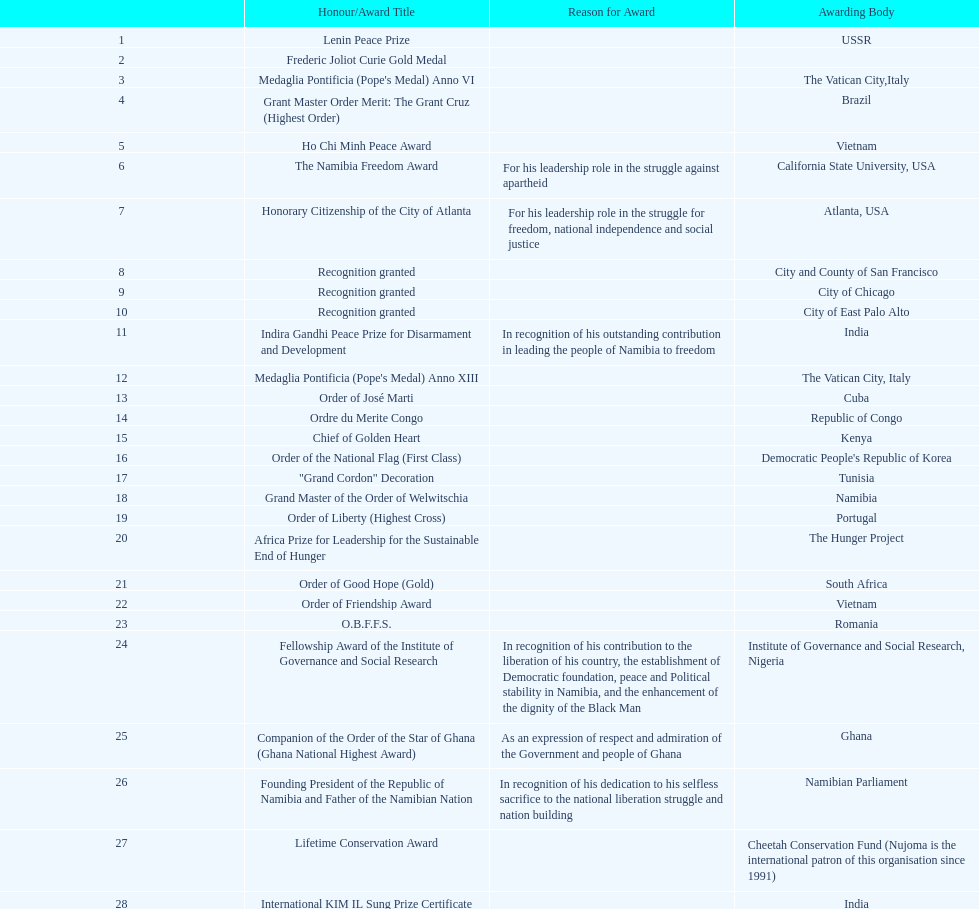Give me the full table as a dictionary. {'header': ['', 'Honour/Award Title', 'Reason for Award', 'Awarding Body'], 'rows': [['1', 'Lenin Peace Prize', '', 'USSR'], ['2', 'Frederic Joliot Curie Gold Medal', '', ''], ['3', "Medaglia Pontificia (Pope's Medal) Anno VI", '', 'The Vatican City,Italy'], ['4', 'Grant Master Order Merit: The Grant Cruz (Highest Order)', '', 'Brazil'], ['5', 'Ho Chi Minh Peace Award', '', 'Vietnam'], ['6', 'The Namibia Freedom Award', 'For his leadership role in the struggle against apartheid', 'California State University, USA'], ['7', 'Honorary Citizenship of the City of Atlanta', 'For his leadership role in the struggle for freedom, national independence and social justice', 'Atlanta, USA'], ['8', 'Recognition granted', '', 'City and County of San Francisco'], ['9', 'Recognition granted', '', 'City of Chicago'], ['10', 'Recognition granted', '', 'City of East Palo Alto'], ['11', 'Indira Gandhi Peace Prize for Disarmament and Development', 'In recognition of his outstanding contribution in leading the people of Namibia to freedom', 'India'], ['12', "Medaglia Pontificia (Pope's Medal) Anno XIII", '', 'The Vatican City, Italy'], ['13', 'Order of José Marti', '', 'Cuba'], ['14', 'Ordre du Merite Congo', '', 'Republic of Congo'], ['15', 'Chief of Golden Heart', '', 'Kenya'], ['16', 'Order of the National Flag (First Class)', '', "Democratic People's Republic of Korea"], ['17', '"Grand Cordon" Decoration', '', 'Tunisia'], ['18', 'Grand Master of the Order of Welwitschia', '', 'Namibia'], ['19', 'Order of Liberty (Highest Cross)', '', 'Portugal'], ['20', 'Africa Prize for Leadership for the Sustainable End of Hunger', '', 'The Hunger Project'], ['21', 'Order of Good Hope (Gold)', '', 'South Africa'], ['22', 'Order of Friendship Award', '', 'Vietnam'], ['23', 'O.B.F.F.S.', '', 'Romania'], ['24', 'Fellowship Award of the Institute of Governance and Social Research', 'In recognition of his contribution to the liberation of his country, the establishment of Democratic foundation, peace and Political stability in Namibia, and the enhancement of the dignity of the Black Man', 'Institute of Governance and Social Research, Nigeria'], ['25', 'Companion of the Order of the Star of Ghana (Ghana National Highest Award)', 'As an expression of respect and admiration of the Government and people of Ghana', 'Ghana'], ['26', 'Founding President of the Republic of Namibia and Father of the Namibian Nation', 'In recognition of his dedication to his selfless sacrifice to the national liberation struggle and nation building', 'Namibian Parliament'], ['27', 'Lifetime Conservation Award', '', 'Cheetah Conservation Fund (Nujoma is the international patron of this organisation since 1991)'], ['28', 'International KIM IL Sung Prize Certificate', '', 'India'], ['29', 'Sir Seretse Khama SADC Meda', '', 'SADC']]} What is the most recent award nujoma received? Sir Seretse Khama SADC Meda. 